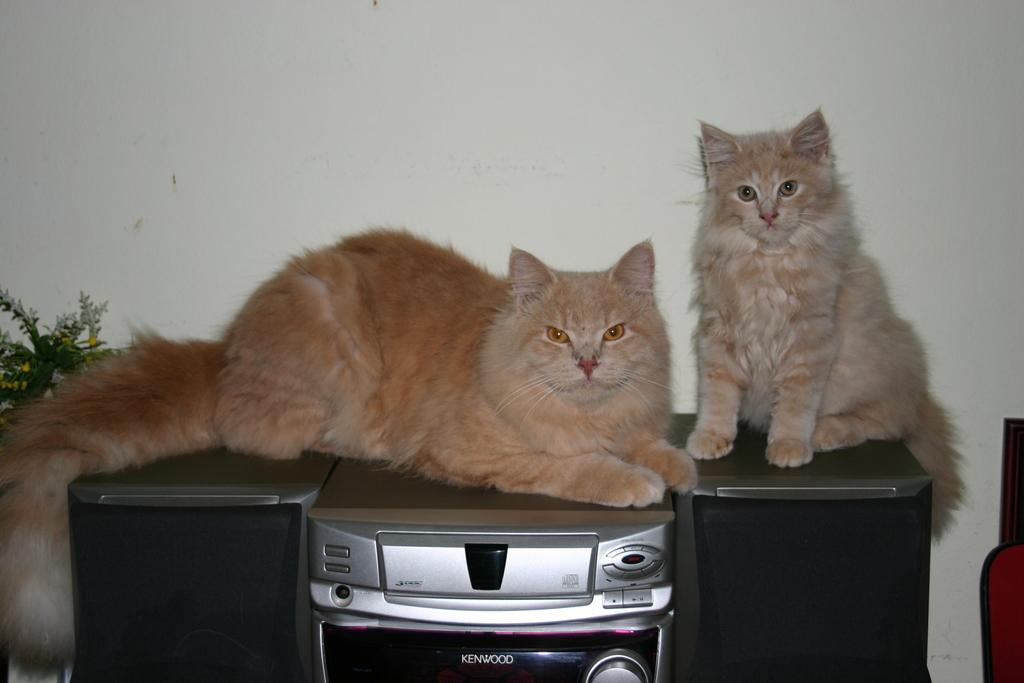What animals are on the music system in the image? There are cats on the music system. What other object is near the cats? There is a plant beside the cats. What can be seen in the background of the image? There is a wall visible in the image. What type of letter is being waved by the cats in the image? There is no letter present in the image, and the cats are not waving anything. 